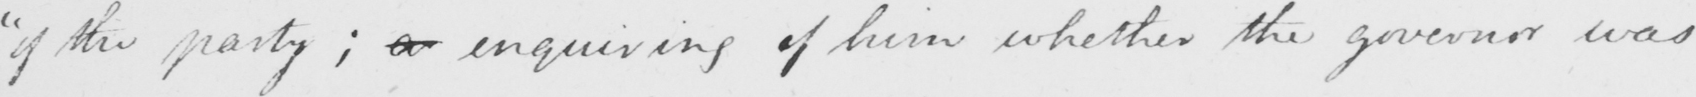Can you read and transcribe this handwriting? " of the party ; enquiring of him whether the governor was 